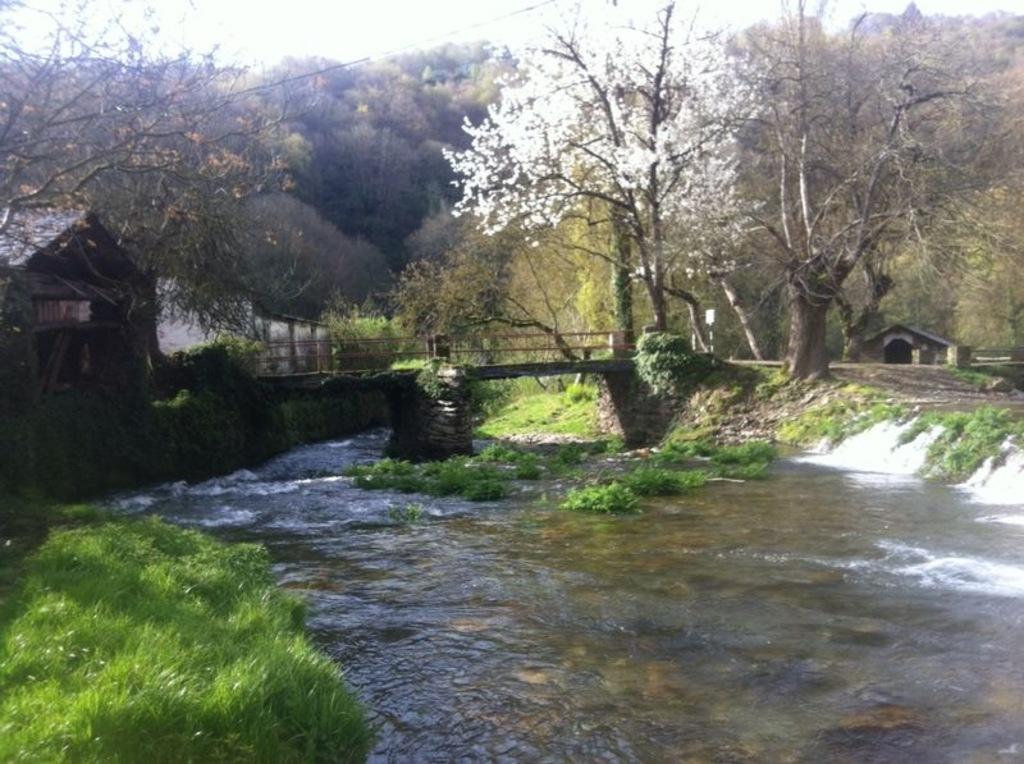Can you describe this image briefly? In the picture I can see trees, a bridge, the grass, a house and the water. In the background I can see a house and the sky. 